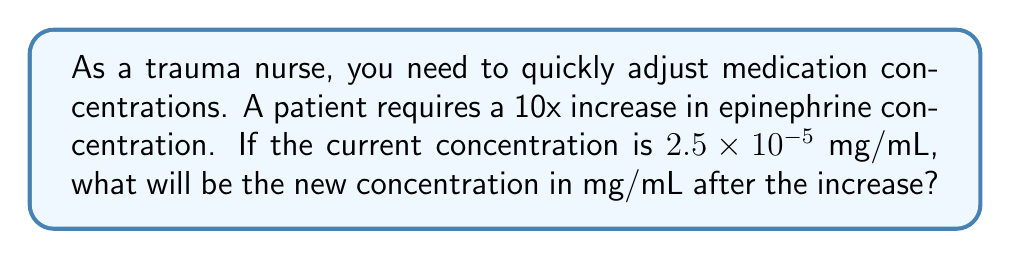Help me with this question. To solve this problem, we need to use the properties of exponents, specifically multiplication with powers of 10.

1. Initial concentration: $2.5 \times 10^{-5}$ mg/mL
2. Increase factor: 10x

To increase a number by a factor of 10, we multiply it by $10^1$. When multiplying numbers in scientific notation, we multiply the coefficients and add the exponents:

$$(2.5 \times 10^{-5}) \times 10^1 = 2.5 \times (10^{-5} \times 10^1)$$

Adding the exponents:

$$2.5 \times 10^{-5+1} = 2.5 \times 10^{-4}$$

Therefore, the new concentration after a 10x increase is $2.5 \times 10^{-4}$ mg/mL.
Answer: $2.5 \times 10^{-4}$ mg/mL 